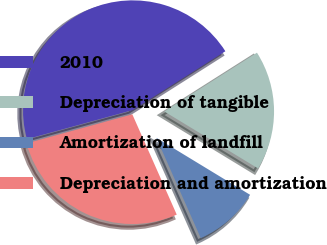Convert chart to OTSL. <chart><loc_0><loc_0><loc_500><loc_500><pie_chart><fcel>2010<fcel>Depreciation of tangible<fcel>Amortization of landfill<fcel>Depreciation and amortization<nl><fcel>45.27%<fcel>17.7%<fcel>9.67%<fcel>27.37%<nl></chart> 